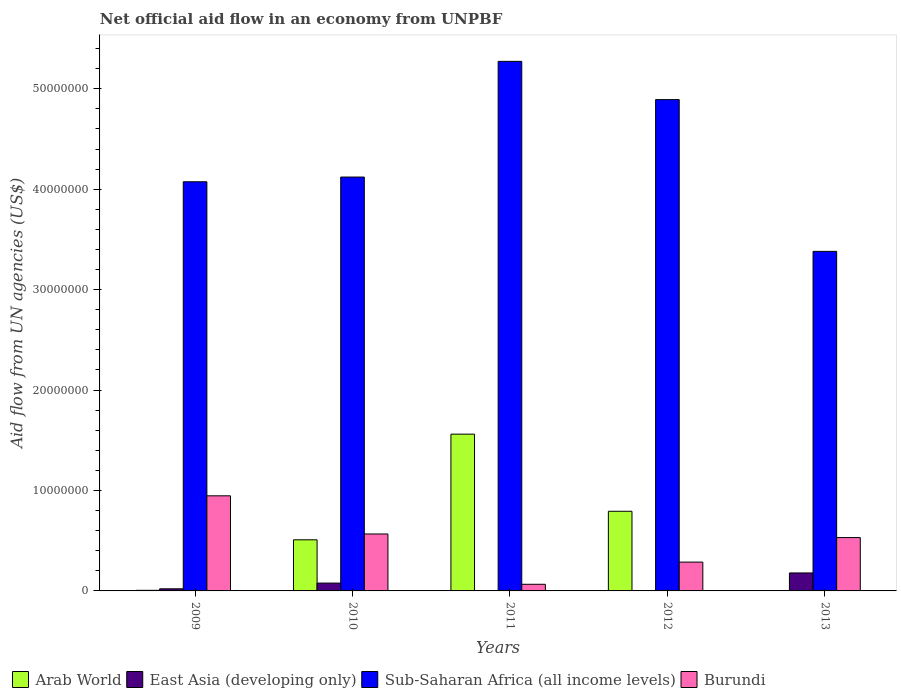How many different coloured bars are there?
Offer a terse response. 4. How many groups of bars are there?
Your answer should be compact. 5. Are the number of bars on each tick of the X-axis equal?
Your response must be concise. No. How many bars are there on the 3rd tick from the left?
Your answer should be compact. 4. How many bars are there on the 5th tick from the right?
Your answer should be very brief. 4. What is the label of the 1st group of bars from the left?
Give a very brief answer. 2009. In how many cases, is the number of bars for a given year not equal to the number of legend labels?
Provide a short and direct response. 1. What is the net official aid flow in Burundi in 2009?
Your response must be concise. 9.47e+06. Across all years, what is the maximum net official aid flow in Arab World?
Your response must be concise. 1.56e+07. Across all years, what is the minimum net official aid flow in Arab World?
Your answer should be compact. 0. What is the total net official aid flow in Arab World in the graph?
Provide a short and direct response. 2.87e+07. What is the difference between the net official aid flow in Arab World in 2010 and that in 2011?
Offer a very short reply. -1.05e+07. What is the difference between the net official aid flow in East Asia (developing only) in 2009 and the net official aid flow in Burundi in 2013?
Give a very brief answer. -5.10e+06. What is the average net official aid flow in Sub-Saharan Africa (all income levels) per year?
Ensure brevity in your answer.  4.35e+07. In the year 2012, what is the difference between the net official aid flow in Burundi and net official aid flow in Sub-Saharan Africa (all income levels)?
Offer a terse response. -4.60e+07. What is the ratio of the net official aid flow in Sub-Saharan Africa (all income levels) in 2010 to that in 2012?
Offer a terse response. 0.84. Is the net official aid flow in Burundi in 2011 less than that in 2012?
Offer a very short reply. Yes. What is the difference between the highest and the second highest net official aid flow in Arab World?
Provide a short and direct response. 7.68e+06. What is the difference between the highest and the lowest net official aid flow in Sub-Saharan Africa (all income levels)?
Provide a short and direct response. 1.89e+07. In how many years, is the net official aid flow in Sub-Saharan Africa (all income levels) greater than the average net official aid flow in Sub-Saharan Africa (all income levels) taken over all years?
Your response must be concise. 2. Is it the case that in every year, the sum of the net official aid flow in Arab World and net official aid flow in East Asia (developing only) is greater than the net official aid flow in Sub-Saharan Africa (all income levels)?
Provide a succinct answer. No. How many bars are there?
Provide a succinct answer. 19. Are all the bars in the graph horizontal?
Keep it short and to the point. No. What is the difference between two consecutive major ticks on the Y-axis?
Make the answer very short. 1.00e+07. Are the values on the major ticks of Y-axis written in scientific E-notation?
Offer a very short reply. No. Where does the legend appear in the graph?
Ensure brevity in your answer.  Bottom left. How are the legend labels stacked?
Make the answer very short. Horizontal. What is the title of the graph?
Offer a very short reply. Net official aid flow in an economy from UNPBF. Does "Curacao" appear as one of the legend labels in the graph?
Offer a terse response. No. What is the label or title of the X-axis?
Keep it short and to the point. Years. What is the label or title of the Y-axis?
Provide a short and direct response. Aid flow from UN agencies (US$). What is the Aid flow from UN agencies (US$) in Arab World in 2009?
Your response must be concise. 6.00e+04. What is the Aid flow from UN agencies (US$) of Sub-Saharan Africa (all income levels) in 2009?
Your answer should be compact. 4.07e+07. What is the Aid flow from UN agencies (US$) of Burundi in 2009?
Provide a succinct answer. 9.47e+06. What is the Aid flow from UN agencies (US$) in Arab World in 2010?
Make the answer very short. 5.09e+06. What is the Aid flow from UN agencies (US$) in East Asia (developing only) in 2010?
Give a very brief answer. 7.80e+05. What is the Aid flow from UN agencies (US$) in Sub-Saharan Africa (all income levels) in 2010?
Your answer should be very brief. 4.12e+07. What is the Aid flow from UN agencies (US$) in Burundi in 2010?
Your answer should be very brief. 5.67e+06. What is the Aid flow from UN agencies (US$) in Arab World in 2011?
Your answer should be compact. 1.56e+07. What is the Aid flow from UN agencies (US$) in East Asia (developing only) in 2011?
Provide a short and direct response. 10000. What is the Aid flow from UN agencies (US$) of Sub-Saharan Africa (all income levels) in 2011?
Make the answer very short. 5.27e+07. What is the Aid flow from UN agencies (US$) in Burundi in 2011?
Ensure brevity in your answer.  6.60e+05. What is the Aid flow from UN agencies (US$) in Arab World in 2012?
Offer a terse response. 7.93e+06. What is the Aid flow from UN agencies (US$) in Sub-Saharan Africa (all income levels) in 2012?
Offer a very short reply. 4.89e+07. What is the Aid flow from UN agencies (US$) in Burundi in 2012?
Your answer should be compact. 2.87e+06. What is the Aid flow from UN agencies (US$) of Arab World in 2013?
Provide a succinct answer. 0. What is the Aid flow from UN agencies (US$) in East Asia (developing only) in 2013?
Offer a very short reply. 1.79e+06. What is the Aid flow from UN agencies (US$) of Sub-Saharan Africa (all income levels) in 2013?
Make the answer very short. 3.38e+07. What is the Aid flow from UN agencies (US$) in Burundi in 2013?
Give a very brief answer. 5.31e+06. Across all years, what is the maximum Aid flow from UN agencies (US$) in Arab World?
Offer a very short reply. 1.56e+07. Across all years, what is the maximum Aid flow from UN agencies (US$) of East Asia (developing only)?
Offer a terse response. 1.79e+06. Across all years, what is the maximum Aid flow from UN agencies (US$) in Sub-Saharan Africa (all income levels)?
Your answer should be compact. 5.27e+07. Across all years, what is the maximum Aid flow from UN agencies (US$) of Burundi?
Your answer should be compact. 9.47e+06. Across all years, what is the minimum Aid flow from UN agencies (US$) of East Asia (developing only)?
Provide a short and direct response. 10000. Across all years, what is the minimum Aid flow from UN agencies (US$) of Sub-Saharan Africa (all income levels)?
Your answer should be compact. 3.38e+07. What is the total Aid flow from UN agencies (US$) of Arab World in the graph?
Your response must be concise. 2.87e+07. What is the total Aid flow from UN agencies (US$) of East Asia (developing only) in the graph?
Your response must be concise. 2.81e+06. What is the total Aid flow from UN agencies (US$) of Sub-Saharan Africa (all income levels) in the graph?
Make the answer very short. 2.17e+08. What is the total Aid flow from UN agencies (US$) of Burundi in the graph?
Give a very brief answer. 2.40e+07. What is the difference between the Aid flow from UN agencies (US$) in Arab World in 2009 and that in 2010?
Make the answer very short. -5.03e+06. What is the difference between the Aid flow from UN agencies (US$) of East Asia (developing only) in 2009 and that in 2010?
Provide a succinct answer. -5.70e+05. What is the difference between the Aid flow from UN agencies (US$) in Sub-Saharan Africa (all income levels) in 2009 and that in 2010?
Your answer should be compact. -4.70e+05. What is the difference between the Aid flow from UN agencies (US$) of Burundi in 2009 and that in 2010?
Provide a short and direct response. 3.80e+06. What is the difference between the Aid flow from UN agencies (US$) in Arab World in 2009 and that in 2011?
Your answer should be very brief. -1.56e+07. What is the difference between the Aid flow from UN agencies (US$) of Sub-Saharan Africa (all income levels) in 2009 and that in 2011?
Offer a very short reply. -1.20e+07. What is the difference between the Aid flow from UN agencies (US$) in Burundi in 2009 and that in 2011?
Make the answer very short. 8.81e+06. What is the difference between the Aid flow from UN agencies (US$) in Arab World in 2009 and that in 2012?
Ensure brevity in your answer.  -7.87e+06. What is the difference between the Aid flow from UN agencies (US$) of Sub-Saharan Africa (all income levels) in 2009 and that in 2012?
Keep it short and to the point. -8.18e+06. What is the difference between the Aid flow from UN agencies (US$) in Burundi in 2009 and that in 2012?
Provide a succinct answer. 6.60e+06. What is the difference between the Aid flow from UN agencies (US$) in East Asia (developing only) in 2009 and that in 2013?
Your answer should be compact. -1.58e+06. What is the difference between the Aid flow from UN agencies (US$) in Sub-Saharan Africa (all income levels) in 2009 and that in 2013?
Your answer should be compact. 6.93e+06. What is the difference between the Aid flow from UN agencies (US$) in Burundi in 2009 and that in 2013?
Give a very brief answer. 4.16e+06. What is the difference between the Aid flow from UN agencies (US$) in Arab World in 2010 and that in 2011?
Make the answer very short. -1.05e+07. What is the difference between the Aid flow from UN agencies (US$) in East Asia (developing only) in 2010 and that in 2011?
Offer a terse response. 7.70e+05. What is the difference between the Aid flow from UN agencies (US$) of Sub-Saharan Africa (all income levels) in 2010 and that in 2011?
Keep it short and to the point. -1.15e+07. What is the difference between the Aid flow from UN agencies (US$) in Burundi in 2010 and that in 2011?
Provide a short and direct response. 5.01e+06. What is the difference between the Aid flow from UN agencies (US$) of Arab World in 2010 and that in 2012?
Give a very brief answer. -2.84e+06. What is the difference between the Aid flow from UN agencies (US$) in East Asia (developing only) in 2010 and that in 2012?
Your answer should be very brief. 7.60e+05. What is the difference between the Aid flow from UN agencies (US$) in Sub-Saharan Africa (all income levels) in 2010 and that in 2012?
Provide a succinct answer. -7.71e+06. What is the difference between the Aid flow from UN agencies (US$) of Burundi in 2010 and that in 2012?
Provide a short and direct response. 2.80e+06. What is the difference between the Aid flow from UN agencies (US$) in East Asia (developing only) in 2010 and that in 2013?
Provide a succinct answer. -1.01e+06. What is the difference between the Aid flow from UN agencies (US$) in Sub-Saharan Africa (all income levels) in 2010 and that in 2013?
Ensure brevity in your answer.  7.40e+06. What is the difference between the Aid flow from UN agencies (US$) of Arab World in 2011 and that in 2012?
Provide a short and direct response. 7.68e+06. What is the difference between the Aid flow from UN agencies (US$) of East Asia (developing only) in 2011 and that in 2012?
Keep it short and to the point. -10000. What is the difference between the Aid flow from UN agencies (US$) of Sub-Saharan Africa (all income levels) in 2011 and that in 2012?
Your response must be concise. 3.81e+06. What is the difference between the Aid flow from UN agencies (US$) in Burundi in 2011 and that in 2012?
Offer a very short reply. -2.21e+06. What is the difference between the Aid flow from UN agencies (US$) in East Asia (developing only) in 2011 and that in 2013?
Your answer should be compact. -1.78e+06. What is the difference between the Aid flow from UN agencies (US$) in Sub-Saharan Africa (all income levels) in 2011 and that in 2013?
Offer a very short reply. 1.89e+07. What is the difference between the Aid flow from UN agencies (US$) of Burundi in 2011 and that in 2013?
Offer a terse response. -4.65e+06. What is the difference between the Aid flow from UN agencies (US$) of East Asia (developing only) in 2012 and that in 2013?
Offer a very short reply. -1.77e+06. What is the difference between the Aid flow from UN agencies (US$) in Sub-Saharan Africa (all income levels) in 2012 and that in 2013?
Keep it short and to the point. 1.51e+07. What is the difference between the Aid flow from UN agencies (US$) of Burundi in 2012 and that in 2013?
Provide a short and direct response. -2.44e+06. What is the difference between the Aid flow from UN agencies (US$) of Arab World in 2009 and the Aid flow from UN agencies (US$) of East Asia (developing only) in 2010?
Your response must be concise. -7.20e+05. What is the difference between the Aid flow from UN agencies (US$) of Arab World in 2009 and the Aid flow from UN agencies (US$) of Sub-Saharan Africa (all income levels) in 2010?
Ensure brevity in your answer.  -4.12e+07. What is the difference between the Aid flow from UN agencies (US$) of Arab World in 2009 and the Aid flow from UN agencies (US$) of Burundi in 2010?
Offer a terse response. -5.61e+06. What is the difference between the Aid flow from UN agencies (US$) of East Asia (developing only) in 2009 and the Aid flow from UN agencies (US$) of Sub-Saharan Africa (all income levels) in 2010?
Your response must be concise. -4.10e+07. What is the difference between the Aid flow from UN agencies (US$) in East Asia (developing only) in 2009 and the Aid flow from UN agencies (US$) in Burundi in 2010?
Offer a very short reply. -5.46e+06. What is the difference between the Aid flow from UN agencies (US$) of Sub-Saharan Africa (all income levels) in 2009 and the Aid flow from UN agencies (US$) of Burundi in 2010?
Give a very brief answer. 3.51e+07. What is the difference between the Aid flow from UN agencies (US$) of Arab World in 2009 and the Aid flow from UN agencies (US$) of East Asia (developing only) in 2011?
Keep it short and to the point. 5.00e+04. What is the difference between the Aid flow from UN agencies (US$) of Arab World in 2009 and the Aid flow from UN agencies (US$) of Sub-Saharan Africa (all income levels) in 2011?
Your answer should be compact. -5.27e+07. What is the difference between the Aid flow from UN agencies (US$) in Arab World in 2009 and the Aid flow from UN agencies (US$) in Burundi in 2011?
Your answer should be very brief. -6.00e+05. What is the difference between the Aid flow from UN agencies (US$) in East Asia (developing only) in 2009 and the Aid flow from UN agencies (US$) in Sub-Saharan Africa (all income levels) in 2011?
Your answer should be compact. -5.25e+07. What is the difference between the Aid flow from UN agencies (US$) in East Asia (developing only) in 2009 and the Aid flow from UN agencies (US$) in Burundi in 2011?
Give a very brief answer. -4.50e+05. What is the difference between the Aid flow from UN agencies (US$) in Sub-Saharan Africa (all income levels) in 2009 and the Aid flow from UN agencies (US$) in Burundi in 2011?
Provide a short and direct response. 4.01e+07. What is the difference between the Aid flow from UN agencies (US$) of Arab World in 2009 and the Aid flow from UN agencies (US$) of East Asia (developing only) in 2012?
Offer a terse response. 4.00e+04. What is the difference between the Aid flow from UN agencies (US$) in Arab World in 2009 and the Aid flow from UN agencies (US$) in Sub-Saharan Africa (all income levels) in 2012?
Your answer should be compact. -4.89e+07. What is the difference between the Aid flow from UN agencies (US$) in Arab World in 2009 and the Aid flow from UN agencies (US$) in Burundi in 2012?
Ensure brevity in your answer.  -2.81e+06. What is the difference between the Aid flow from UN agencies (US$) of East Asia (developing only) in 2009 and the Aid flow from UN agencies (US$) of Sub-Saharan Africa (all income levels) in 2012?
Offer a terse response. -4.87e+07. What is the difference between the Aid flow from UN agencies (US$) in East Asia (developing only) in 2009 and the Aid flow from UN agencies (US$) in Burundi in 2012?
Your response must be concise. -2.66e+06. What is the difference between the Aid flow from UN agencies (US$) of Sub-Saharan Africa (all income levels) in 2009 and the Aid flow from UN agencies (US$) of Burundi in 2012?
Offer a very short reply. 3.79e+07. What is the difference between the Aid flow from UN agencies (US$) in Arab World in 2009 and the Aid flow from UN agencies (US$) in East Asia (developing only) in 2013?
Offer a very short reply. -1.73e+06. What is the difference between the Aid flow from UN agencies (US$) of Arab World in 2009 and the Aid flow from UN agencies (US$) of Sub-Saharan Africa (all income levels) in 2013?
Offer a terse response. -3.38e+07. What is the difference between the Aid flow from UN agencies (US$) of Arab World in 2009 and the Aid flow from UN agencies (US$) of Burundi in 2013?
Ensure brevity in your answer.  -5.25e+06. What is the difference between the Aid flow from UN agencies (US$) in East Asia (developing only) in 2009 and the Aid flow from UN agencies (US$) in Sub-Saharan Africa (all income levels) in 2013?
Give a very brief answer. -3.36e+07. What is the difference between the Aid flow from UN agencies (US$) of East Asia (developing only) in 2009 and the Aid flow from UN agencies (US$) of Burundi in 2013?
Provide a succinct answer. -5.10e+06. What is the difference between the Aid flow from UN agencies (US$) of Sub-Saharan Africa (all income levels) in 2009 and the Aid flow from UN agencies (US$) of Burundi in 2013?
Ensure brevity in your answer.  3.54e+07. What is the difference between the Aid flow from UN agencies (US$) in Arab World in 2010 and the Aid flow from UN agencies (US$) in East Asia (developing only) in 2011?
Give a very brief answer. 5.08e+06. What is the difference between the Aid flow from UN agencies (US$) in Arab World in 2010 and the Aid flow from UN agencies (US$) in Sub-Saharan Africa (all income levels) in 2011?
Your answer should be very brief. -4.76e+07. What is the difference between the Aid flow from UN agencies (US$) of Arab World in 2010 and the Aid flow from UN agencies (US$) of Burundi in 2011?
Your answer should be compact. 4.43e+06. What is the difference between the Aid flow from UN agencies (US$) in East Asia (developing only) in 2010 and the Aid flow from UN agencies (US$) in Sub-Saharan Africa (all income levels) in 2011?
Provide a succinct answer. -5.20e+07. What is the difference between the Aid flow from UN agencies (US$) in Sub-Saharan Africa (all income levels) in 2010 and the Aid flow from UN agencies (US$) in Burundi in 2011?
Your answer should be very brief. 4.06e+07. What is the difference between the Aid flow from UN agencies (US$) in Arab World in 2010 and the Aid flow from UN agencies (US$) in East Asia (developing only) in 2012?
Keep it short and to the point. 5.07e+06. What is the difference between the Aid flow from UN agencies (US$) of Arab World in 2010 and the Aid flow from UN agencies (US$) of Sub-Saharan Africa (all income levels) in 2012?
Ensure brevity in your answer.  -4.38e+07. What is the difference between the Aid flow from UN agencies (US$) in Arab World in 2010 and the Aid flow from UN agencies (US$) in Burundi in 2012?
Ensure brevity in your answer.  2.22e+06. What is the difference between the Aid flow from UN agencies (US$) of East Asia (developing only) in 2010 and the Aid flow from UN agencies (US$) of Sub-Saharan Africa (all income levels) in 2012?
Make the answer very short. -4.81e+07. What is the difference between the Aid flow from UN agencies (US$) of East Asia (developing only) in 2010 and the Aid flow from UN agencies (US$) of Burundi in 2012?
Keep it short and to the point. -2.09e+06. What is the difference between the Aid flow from UN agencies (US$) in Sub-Saharan Africa (all income levels) in 2010 and the Aid flow from UN agencies (US$) in Burundi in 2012?
Make the answer very short. 3.83e+07. What is the difference between the Aid flow from UN agencies (US$) in Arab World in 2010 and the Aid flow from UN agencies (US$) in East Asia (developing only) in 2013?
Your answer should be very brief. 3.30e+06. What is the difference between the Aid flow from UN agencies (US$) of Arab World in 2010 and the Aid flow from UN agencies (US$) of Sub-Saharan Africa (all income levels) in 2013?
Your answer should be compact. -2.87e+07. What is the difference between the Aid flow from UN agencies (US$) in East Asia (developing only) in 2010 and the Aid flow from UN agencies (US$) in Sub-Saharan Africa (all income levels) in 2013?
Make the answer very short. -3.30e+07. What is the difference between the Aid flow from UN agencies (US$) in East Asia (developing only) in 2010 and the Aid flow from UN agencies (US$) in Burundi in 2013?
Make the answer very short. -4.53e+06. What is the difference between the Aid flow from UN agencies (US$) in Sub-Saharan Africa (all income levels) in 2010 and the Aid flow from UN agencies (US$) in Burundi in 2013?
Offer a very short reply. 3.59e+07. What is the difference between the Aid flow from UN agencies (US$) in Arab World in 2011 and the Aid flow from UN agencies (US$) in East Asia (developing only) in 2012?
Provide a short and direct response. 1.56e+07. What is the difference between the Aid flow from UN agencies (US$) of Arab World in 2011 and the Aid flow from UN agencies (US$) of Sub-Saharan Africa (all income levels) in 2012?
Offer a very short reply. -3.33e+07. What is the difference between the Aid flow from UN agencies (US$) in Arab World in 2011 and the Aid flow from UN agencies (US$) in Burundi in 2012?
Provide a short and direct response. 1.27e+07. What is the difference between the Aid flow from UN agencies (US$) of East Asia (developing only) in 2011 and the Aid flow from UN agencies (US$) of Sub-Saharan Africa (all income levels) in 2012?
Give a very brief answer. -4.89e+07. What is the difference between the Aid flow from UN agencies (US$) of East Asia (developing only) in 2011 and the Aid flow from UN agencies (US$) of Burundi in 2012?
Your answer should be very brief. -2.86e+06. What is the difference between the Aid flow from UN agencies (US$) of Sub-Saharan Africa (all income levels) in 2011 and the Aid flow from UN agencies (US$) of Burundi in 2012?
Provide a short and direct response. 4.99e+07. What is the difference between the Aid flow from UN agencies (US$) in Arab World in 2011 and the Aid flow from UN agencies (US$) in East Asia (developing only) in 2013?
Make the answer very short. 1.38e+07. What is the difference between the Aid flow from UN agencies (US$) of Arab World in 2011 and the Aid flow from UN agencies (US$) of Sub-Saharan Africa (all income levels) in 2013?
Your answer should be very brief. -1.82e+07. What is the difference between the Aid flow from UN agencies (US$) of Arab World in 2011 and the Aid flow from UN agencies (US$) of Burundi in 2013?
Make the answer very short. 1.03e+07. What is the difference between the Aid flow from UN agencies (US$) of East Asia (developing only) in 2011 and the Aid flow from UN agencies (US$) of Sub-Saharan Africa (all income levels) in 2013?
Provide a short and direct response. -3.38e+07. What is the difference between the Aid flow from UN agencies (US$) of East Asia (developing only) in 2011 and the Aid flow from UN agencies (US$) of Burundi in 2013?
Your answer should be compact. -5.30e+06. What is the difference between the Aid flow from UN agencies (US$) in Sub-Saharan Africa (all income levels) in 2011 and the Aid flow from UN agencies (US$) in Burundi in 2013?
Your response must be concise. 4.74e+07. What is the difference between the Aid flow from UN agencies (US$) in Arab World in 2012 and the Aid flow from UN agencies (US$) in East Asia (developing only) in 2013?
Your response must be concise. 6.14e+06. What is the difference between the Aid flow from UN agencies (US$) of Arab World in 2012 and the Aid flow from UN agencies (US$) of Sub-Saharan Africa (all income levels) in 2013?
Your answer should be compact. -2.59e+07. What is the difference between the Aid flow from UN agencies (US$) of Arab World in 2012 and the Aid flow from UN agencies (US$) of Burundi in 2013?
Your answer should be compact. 2.62e+06. What is the difference between the Aid flow from UN agencies (US$) of East Asia (developing only) in 2012 and the Aid flow from UN agencies (US$) of Sub-Saharan Africa (all income levels) in 2013?
Offer a very short reply. -3.38e+07. What is the difference between the Aid flow from UN agencies (US$) of East Asia (developing only) in 2012 and the Aid flow from UN agencies (US$) of Burundi in 2013?
Offer a very short reply. -5.29e+06. What is the difference between the Aid flow from UN agencies (US$) of Sub-Saharan Africa (all income levels) in 2012 and the Aid flow from UN agencies (US$) of Burundi in 2013?
Offer a terse response. 4.36e+07. What is the average Aid flow from UN agencies (US$) of Arab World per year?
Offer a very short reply. 5.74e+06. What is the average Aid flow from UN agencies (US$) in East Asia (developing only) per year?
Offer a very short reply. 5.62e+05. What is the average Aid flow from UN agencies (US$) in Sub-Saharan Africa (all income levels) per year?
Offer a terse response. 4.35e+07. What is the average Aid flow from UN agencies (US$) of Burundi per year?
Your response must be concise. 4.80e+06. In the year 2009, what is the difference between the Aid flow from UN agencies (US$) of Arab World and Aid flow from UN agencies (US$) of Sub-Saharan Africa (all income levels)?
Make the answer very short. -4.07e+07. In the year 2009, what is the difference between the Aid flow from UN agencies (US$) of Arab World and Aid flow from UN agencies (US$) of Burundi?
Provide a short and direct response. -9.41e+06. In the year 2009, what is the difference between the Aid flow from UN agencies (US$) in East Asia (developing only) and Aid flow from UN agencies (US$) in Sub-Saharan Africa (all income levels)?
Provide a short and direct response. -4.05e+07. In the year 2009, what is the difference between the Aid flow from UN agencies (US$) of East Asia (developing only) and Aid flow from UN agencies (US$) of Burundi?
Your answer should be compact. -9.26e+06. In the year 2009, what is the difference between the Aid flow from UN agencies (US$) of Sub-Saharan Africa (all income levels) and Aid flow from UN agencies (US$) of Burundi?
Your answer should be compact. 3.13e+07. In the year 2010, what is the difference between the Aid flow from UN agencies (US$) of Arab World and Aid flow from UN agencies (US$) of East Asia (developing only)?
Ensure brevity in your answer.  4.31e+06. In the year 2010, what is the difference between the Aid flow from UN agencies (US$) of Arab World and Aid flow from UN agencies (US$) of Sub-Saharan Africa (all income levels)?
Keep it short and to the point. -3.61e+07. In the year 2010, what is the difference between the Aid flow from UN agencies (US$) in Arab World and Aid flow from UN agencies (US$) in Burundi?
Offer a very short reply. -5.80e+05. In the year 2010, what is the difference between the Aid flow from UN agencies (US$) of East Asia (developing only) and Aid flow from UN agencies (US$) of Sub-Saharan Africa (all income levels)?
Provide a short and direct response. -4.04e+07. In the year 2010, what is the difference between the Aid flow from UN agencies (US$) of East Asia (developing only) and Aid flow from UN agencies (US$) of Burundi?
Offer a terse response. -4.89e+06. In the year 2010, what is the difference between the Aid flow from UN agencies (US$) in Sub-Saharan Africa (all income levels) and Aid flow from UN agencies (US$) in Burundi?
Offer a terse response. 3.55e+07. In the year 2011, what is the difference between the Aid flow from UN agencies (US$) of Arab World and Aid flow from UN agencies (US$) of East Asia (developing only)?
Provide a succinct answer. 1.56e+07. In the year 2011, what is the difference between the Aid flow from UN agencies (US$) of Arab World and Aid flow from UN agencies (US$) of Sub-Saharan Africa (all income levels)?
Your answer should be very brief. -3.71e+07. In the year 2011, what is the difference between the Aid flow from UN agencies (US$) of Arab World and Aid flow from UN agencies (US$) of Burundi?
Ensure brevity in your answer.  1.50e+07. In the year 2011, what is the difference between the Aid flow from UN agencies (US$) of East Asia (developing only) and Aid flow from UN agencies (US$) of Sub-Saharan Africa (all income levels)?
Make the answer very short. -5.27e+07. In the year 2011, what is the difference between the Aid flow from UN agencies (US$) of East Asia (developing only) and Aid flow from UN agencies (US$) of Burundi?
Keep it short and to the point. -6.50e+05. In the year 2011, what is the difference between the Aid flow from UN agencies (US$) of Sub-Saharan Africa (all income levels) and Aid flow from UN agencies (US$) of Burundi?
Ensure brevity in your answer.  5.21e+07. In the year 2012, what is the difference between the Aid flow from UN agencies (US$) of Arab World and Aid flow from UN agencies (US$) of East Asia (developing only)?
Offer a very short reply. 7.91e+06. In the year 2012, what is the difference between the Aid flow from UN agencies (US$) of Arab World and Aid flow from UN agencies (US$) of Sub-Saharan Africa (all income levels)?
Your answer should be compact. -4.10e+07. In the year 2012, what is the difference between the Aid flow from UN agencies (US$) of Arab World and Aid flow from UN agencies (US$) of Burundi?
Provide a short and direct response. 5.06e+06. In the year 2012, what is the difference between the Aid flow from UN agencies (US$) of East Asia (developing only) and Aid flow from UN agencies (US$) of Sub-Saharan Africa (all income levels)?
Your response must be concise. -4.89e+07. In the year 2012, what is the difference between the Aid flow from UN agencies (US$) of East Asia (developing only) and Aid flow from UN agencies (US$) of Burundi?
Offer a terse response. -2.85e+06. In the year 2012, what is the difference between the Aid flow from UN agencies (US$) in Sub-Saharan Africa (all income levels) and Aid flow from UN agencies (US$) in Burundi?
Make the answer very short. 4.60e+07. In the year 2013, what is the difference between the Aid flow from UN agencies (US$) of East Asia (developing only) and Aid flow from UN agencies (US$) of Sub-Saharan Africa (all income levels)?
Provide a succinct answer. -3.20e+07. In the year 2013, what is the difference between the Aid flow from UN agencies (US$) in East Asia (developing only) and Aid flow from UN agencies (US$) in Burundi?
Offer a very short reply. -3.52e+06. In the year 2013, what is the difference between the Aid flow from UN agencies (US$) in Sub-Saharan Africa (all income levels) and Aid flow from UN agencies (US$) in Burundi?
Your answer should be compact. 2.85e+07. What is the ratio of the Aid flow from UN agencies (US$) in Arab World in 2009 to that in 2010?
Your answer should be very brief. 0.01. What is the ratio of the Aid flow from UN agencies (US$) in East Asia (developing only) in 2009 to that in 2010?
Keep it short and to the point. 0.27. What is the ratio of the Aid flow from UN agencies (US$) in Burundi in 2009 to that in 2010?
Offer a terse response. 1.67. What is the ratio of the Aid flow from UN agencies (US$) in Arab World in 2009 to that in 2011?
Offer a terse response. 0. What is the ratio of the Aid flow from UN agencies (US$) in East Asia (developing only) in 2009 to that in 2011?
Your response must be concise. 21. What is the ratio of the Aid flow from UN agencies (US$) in Sub-Saharan Africa (all income levels) in 2009 to that in 2011?
Ensure brevity in your answer.  0.77. What is the ratio of the Aid flow from UN agencies (US$) of Burundi in 2009 to that in 2011?
Make the answer very short. 14.35. What is the ratio of the Aid flow from UN agencies (US$) in Arab World in 2009 to that in 2012?
Your answer should be very brief. 0.01. What is the ratio of the Aid flow from UN agencies (US$) of East Asia (developing only) in 2009 to that in 2012?
Offer a terse response. 10.5. What is the ratio of the Aid flow from UN agencies (US$) in Sub-Saharan Africa (all income levels) in 2009 to that in 2012?
Make the answer very short. 0.83. What is the ratio of the Aid flow from UN agencies (US$) of Burundi in 2009 to that in 2012?
Provide a succinct answer. 3.3. What is the ratio of the Aid flow from UN agencies (US$) of East Asia (developing only) in 2009 to that in 2013?
Provide a succinct answer. 0.12. What is the ratio of the Aid flow from UN agencies (US$) of Sub-Saharan Africa (all income levels) in 2009 to that in 2013?
Your response must be concise. 1.21. What is the ratio of the Aid flow from UN agencies (US$) in Burundi in 2009 to that in 2013?
Offer a very short reply. 1.78. What is the ratio of the Aid flow from UN agencies (US$) of Arab World in 2010 to that in 2011?
Your answer should be compact. 0.33. What is the ratio of the Aid flow from UN agencies (US$) in East Asia (developing only) in 2010 to that in 2011?
Your response must be concise. 78. What is the ratio of the Aid flow from UN agencies (US$) of Sub-Saharan Africa (all income levels) in 2010 to that in 2011?
Keep it short and to the point. 0.78. What is the ratio of the Aid flow from UN agencies (US$) in Burundi in 2010 to that in 2011?
Your answer should be very brief. 8.59. What is the ratio of the Aid flow from UN agencies (US$) in Arab World in 2010 to that in 2012?
Provide a short and direct response. 0.64. What is the ratio of the Aid flow from UN agencies (US$) in Sub-Saharan Africa (all income levels) in 2010 to that in 2012?
Your response must be concise. 0.84. What is the ratio of the Aid flow from UN agencies (US$) in Burundi in 2010 to that in 2012?
Your response must be concise. 1.98. What is the ratio of the Aid flow from UN agencies (US$) of East Asia (developing only) in 2010 to that in 2013?
Offer a terse response. 0.44. What is the ratio of the Aid flow from UN agencies (US$) of Sub-Saharan Africa (all income levels) in 2010 to that in 2013?
Provide a succinct answer. 1.22. What is the ratio of the Aid flow from UN agencies (US$) of Burundi in 2010 to that in 2013?
Provide a succinct answer. 1.07. What is the ratio of the Aid flow from UN agencies (US$) of Arab World in 2011 to that in 2012?
Ensure brevity in your answer.  1.97. What is the ratio of the Aid flow from UN agencies (US$) of East Asia (developing only) in 2011 to that in 2012?
Offer a terse response. 0.5. What is the ratio of the Aid flow from UN agencies (US$) in Sub-Saharan Africa (all income levels) in 2011 to that in 2012?
Make the answer very short. 1.08. What is the ratio of the Aid flow from UN agencies (US$) in Burundi in 2011 to that in 2012?
Your response must be concise. 0.23. What is the ratio of the Aid flow from UN agencies (US$) of East Asia (developing only) in 2011 to that in 2013?
Offer a very short reply. 0.01. What is the ratio of the Aid flow from UN agencies (US$) in Sub-Saharan Africa (all income levels) in 2011 to that in 2013?
Your answer should be very brief. 1.56. What is the ratio of the Aid flow from UN agencies (US$) in Burundi in 2011 to that in 2013?
Your answer should be very brief. 0.12. What is the ratio of the Aid flow from UN agencies (US$) in East Asia (developing only) in 2012 to that in 2013?
Your answer should be compact. 0.01. What is the ratio of the Aid flow from UN agencies (US$) of Sub-Saharan Africa (all income levels) in 2012 to that in 2013?
Make the answer very short. 1.45. What is the ratio of the Aid flow from UN agencies (US$) of Burundi in 2012 to that in 2013?
Make the answer very short. 0.54. What is the difference between the highest and the second highest Aid flow from UN agencies (US$) of Arab World?
Make the answer very short. 7.68e+06. What is the difference between the highest and the second highest Aid flow from UN agencies (US$) in East Asia (developing only)?
Provide a short and direct response. 1.01e+06. What is the difference between the highest and the second highest Aid flow from UN agencies (US$) of Sub-Saharan Africa (all income levels)?
Your answer should be compact. 3.81e+06. What is the difference between the highest and the second highest Aid flow from UN agencies (US$) of Burundi?
Provide a succinct answer. 3.80e+06. What is the difference between the highest and the lowest Aid flow from UN agencies (US$) in Arab World?
Give a very brief answer. 1.56e+07. What is the difference between the highest and the lowest Aid flow from UN agencies (US$) in East Asia (developing only)?
Your answer should be very brief. 1.78e+06. What is the difference between the highest and the lowest Aid flow from UN agencies (US$) in Sub-Saharan Africa (all income levels)?
Ensure brevity in your answer.  1.89e+07. What is the difference between the highest and the lowest Aid flow from UN agencies (US$) in Burundi?
Your answer should be very brief. 8.81e+06. 